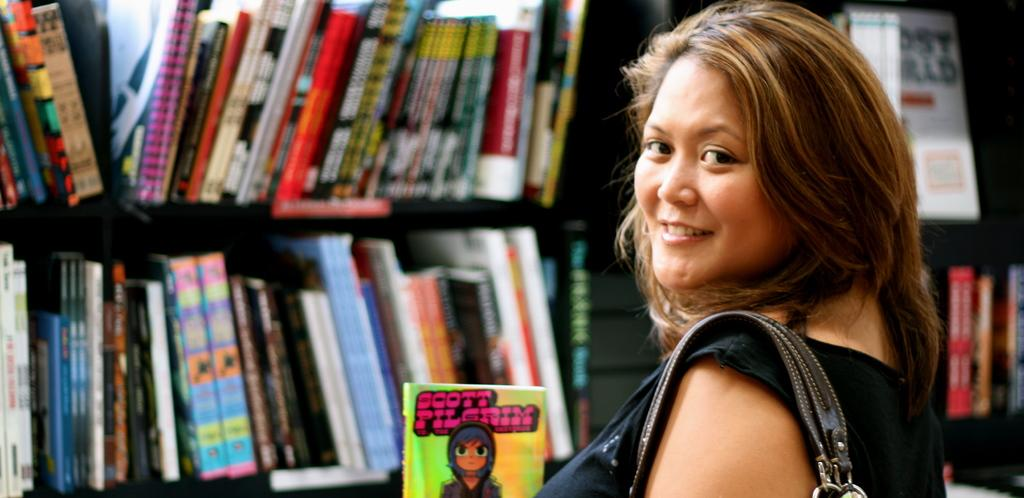Provide a one-sentence caption for the provided image. Woman stands in front of bookshelves full of books holding up a Scott Pilgrim book with its front cover facing forward. 